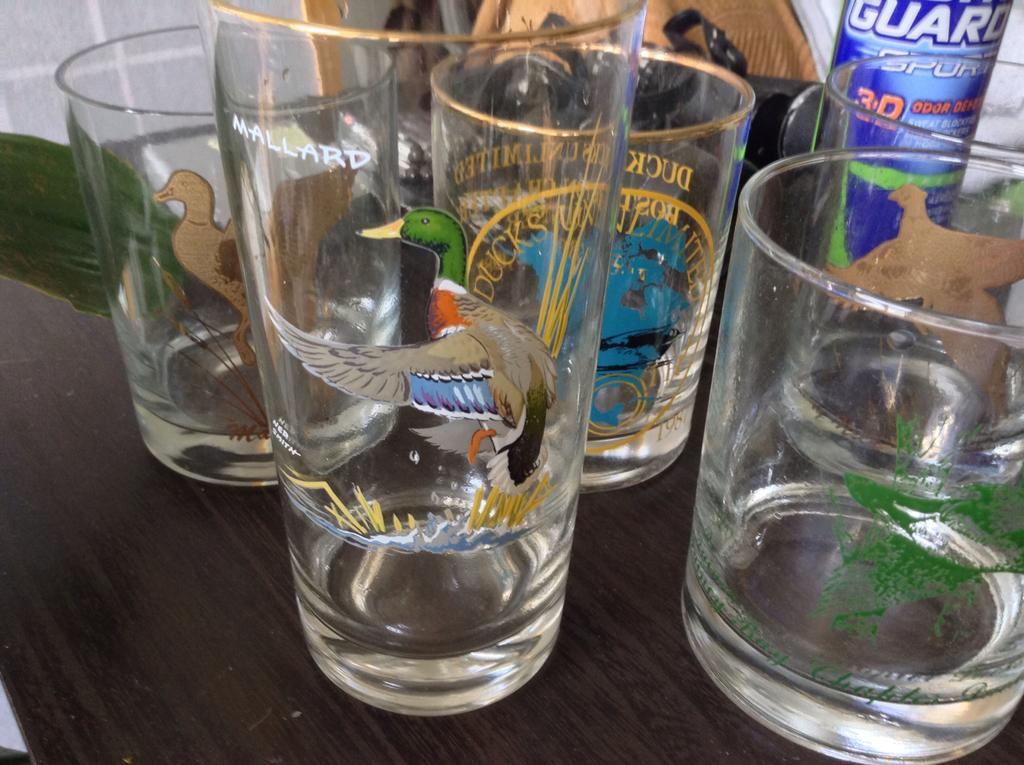What can be found on the table in the image? There are glasses on the table. What else is present on the table besides the glasses? There are other objects on the table. What is unique about the glasses in the image? The glasses have paintings on them. What can be seen in the background of the image? There is a wall and green leaves visible in the background. How many tickets are visible in the image? There are no tickets present in the image. What type of yam is being used as a decoration in the image? There is no yam present in the image. 